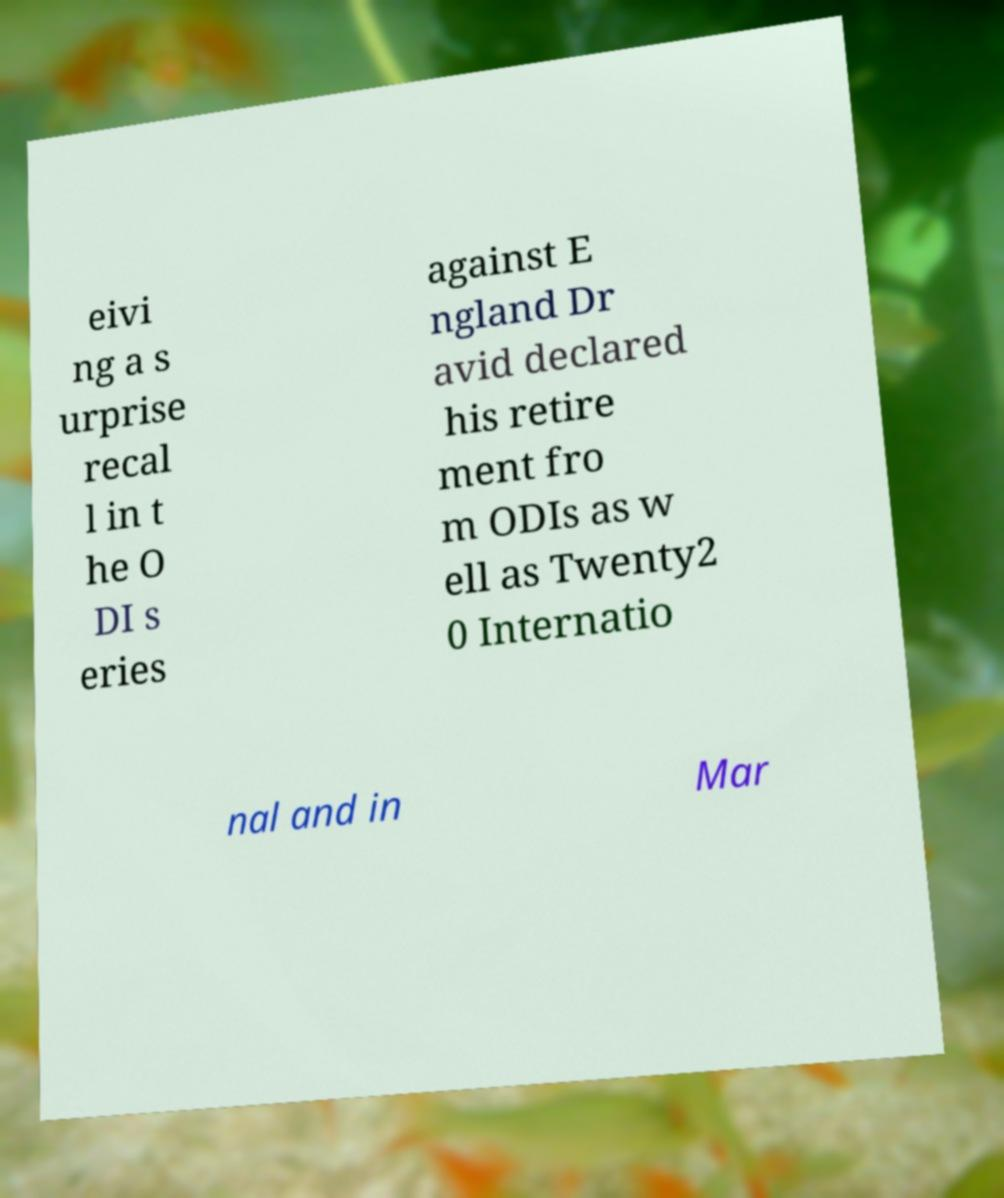Can you accurately transcribe the text from the provided image for me? eivi ng a s urprise recal l in t he O DI s eries against E ngland Dr avid declared his retire ment fro m ODIs as w ell as Twenty2 0 Internatio nal and in Mar 